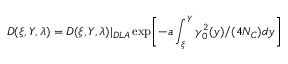Convert formula to latex. <formula><loc_0><loc_0><loc_500><loc_500>D ( \xi , Y , \lambda ) = D ( \xi , Y , \lambda ) | _ { D L A } \exp \left [ - a \int _ { \xi } ^ { Y } \gamma _ { 0 } ^ { 2 } ( y ) / ( 4 N _ { C } ) d y \right ]</formula> 